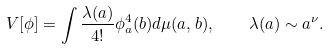<formula> <loc_0><loc_0><loc_500><loc_500>V [ \phi ] = \int \frac { \lambda ( a ) } { 4 ! } \phi ^ { 4 } _ { a } ( b ) d \mu ( a , b ) , \quad \lambda ( a ) \sim a ^ { \nu } .</formula> 